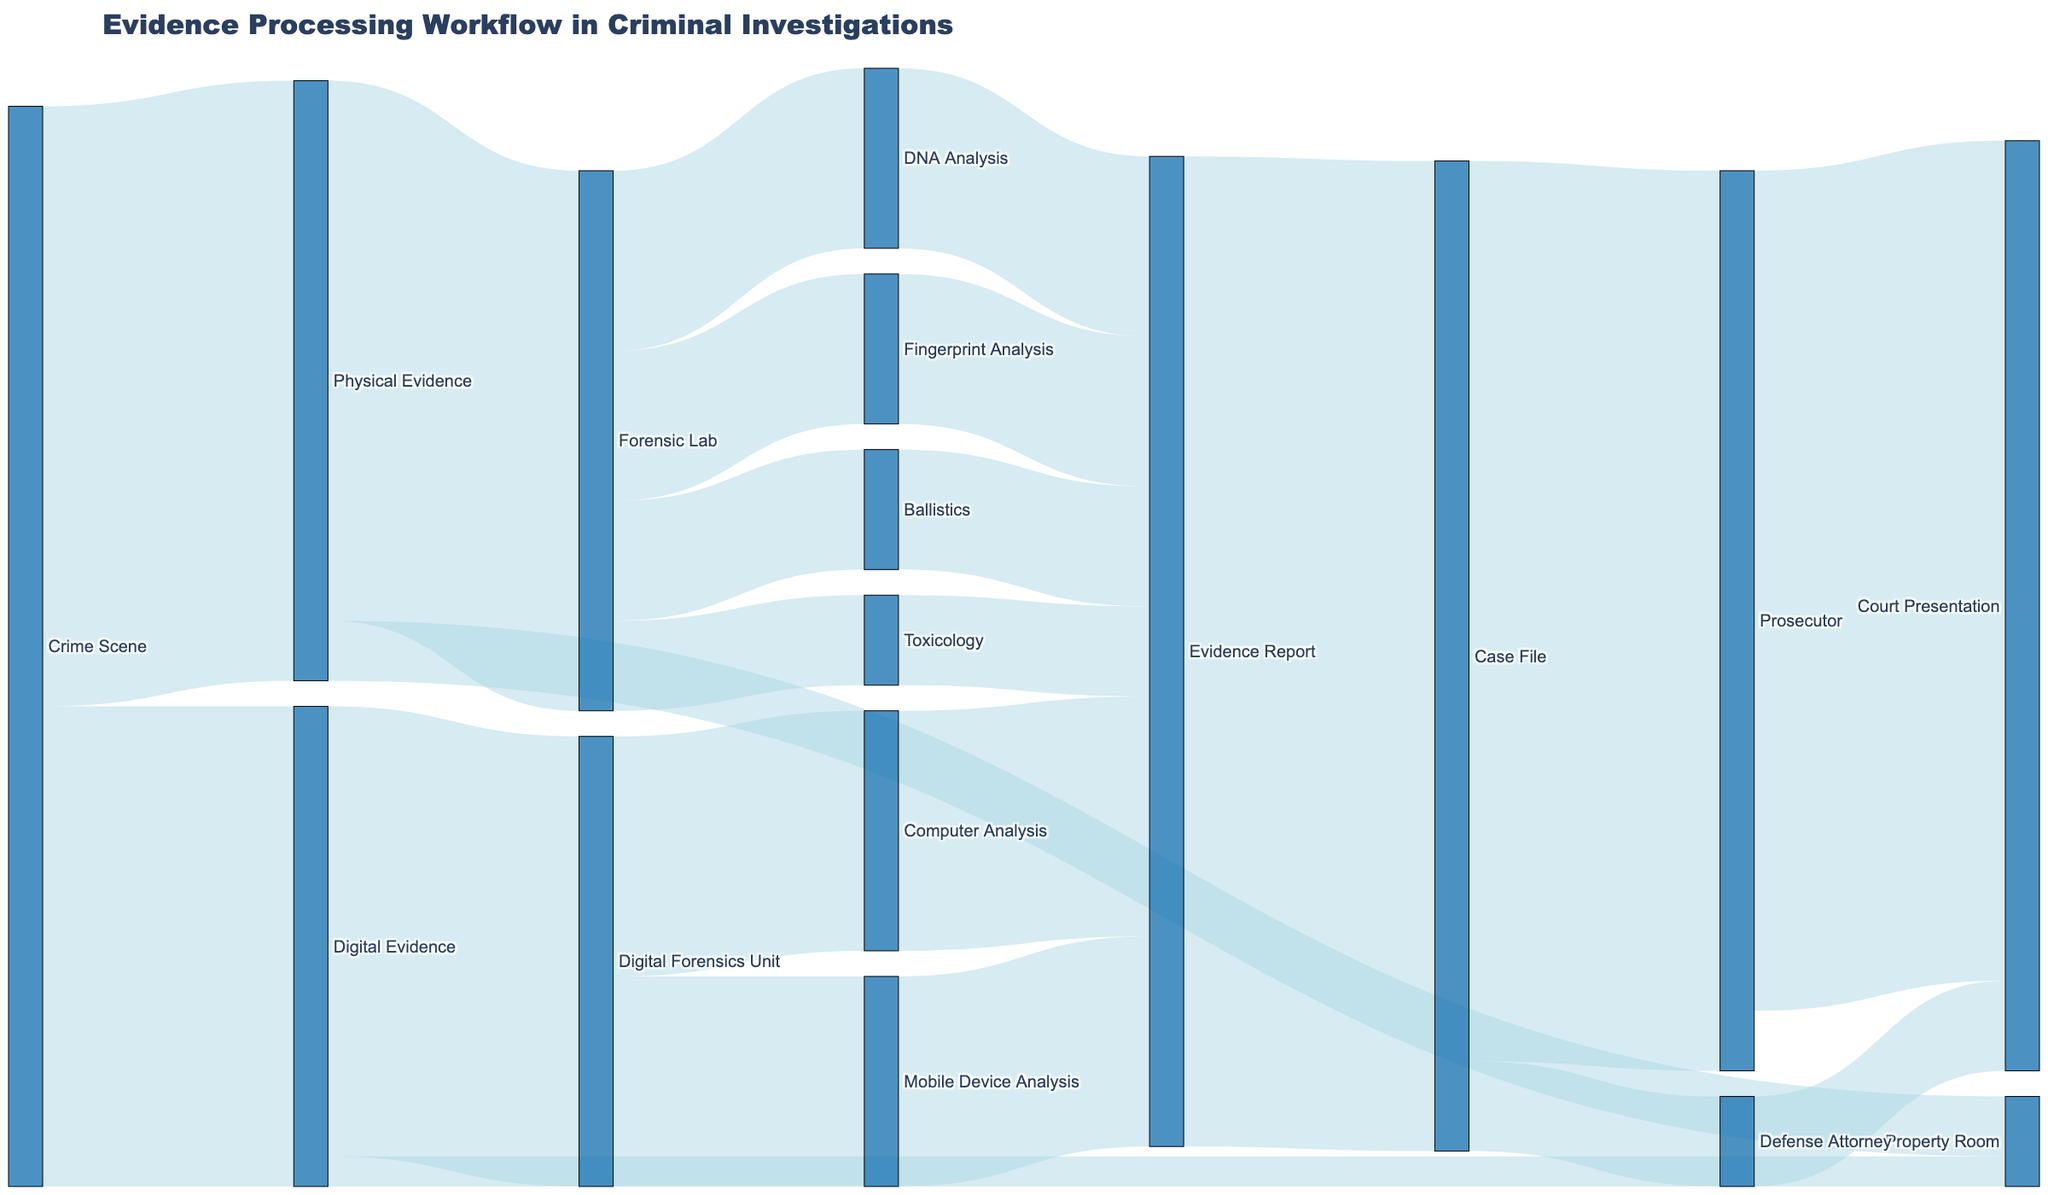What is the title of the figure? The title is usually located at the top of the figure, and it summarizes what the figure is about. Here, it should be fairly prominent.
Answer: Evidence Processing Workflow in Criminal Investigations What are the two types of evidence collected at the crime scene? The figure shows the different types of evidence collected from the crime scene at the initial stage. The lines connecting nodes indicate they are "Physical Evidence" and "Digital Evidence".
Answer: Physical Evidence and Digital Evidence How many units of physical evidence are processed by the forensic lab? The thickness of the lines from "Physical Evidence" to "Forensic Lab" indicates the number of units processed. The value listed is 90.
Answer: 90 What is the total amount of evidence that eventually gets included in the case file? To get this, sum the values of all the lines leading to "Case File". Summing the values from "Evidence Report" gives 165 units.
Answer: 165 Which type of evidence has the smallest amount directed to the property room? By comparing the values of lines directed to the property room, "Digital Evidence" has 5 units, which is smaller than the 10 units from "Physical Evidence".
Answer: Digital Evidence What percentage of the Prosecutor's evidence make it to court presentation? The prosecutor receives 150 units and sends 140 units to court. Calculating the percentage: (140/150) * 100 = 93.33%
Answer: 93.33% How many units of digital evidence are processed by the Digital Forensics Unit? The line connecting "Digital Evidence" to "Digital Forensics Unit" indicates this value, which is 75 units.
Answer: 75 What is the total number of different analysis steps conducted by the forensic lab? The forensic lab processes evidence into different categories, totaling the distinct types: DNA Analysis, Fingerprint Analysis, Ballistics, and Toxicology, which are four different steps.
Answer: 4 Compare the number of units analyzed by Fingerprint Analysis and Mobile Device Analysis. Which is higher? Fingerprint Analysis handles 25 units, while Mobile Device Analysis handles 35 units. Comparing these, Mobile Device Analysis handles more units.
Answer: Mobile Device Analysis List all steps involved in processing digital evidence from collection to court presentation. The flow from "Digital Evidence" can be followed through "Digital Forensics Unit," then through analysis steps like "Computer Analysis" or "Mobile Device Analysis," resulting in "Evidence Report," "Case File," "Prosecutor," and finally "Court Presentation."
Answer: Digital Evidence, Digital Forensics Unit, Computer Analysis/Mobile Device Analysis, Evidence Report, Case File, Prosecutor, Court Presentation 